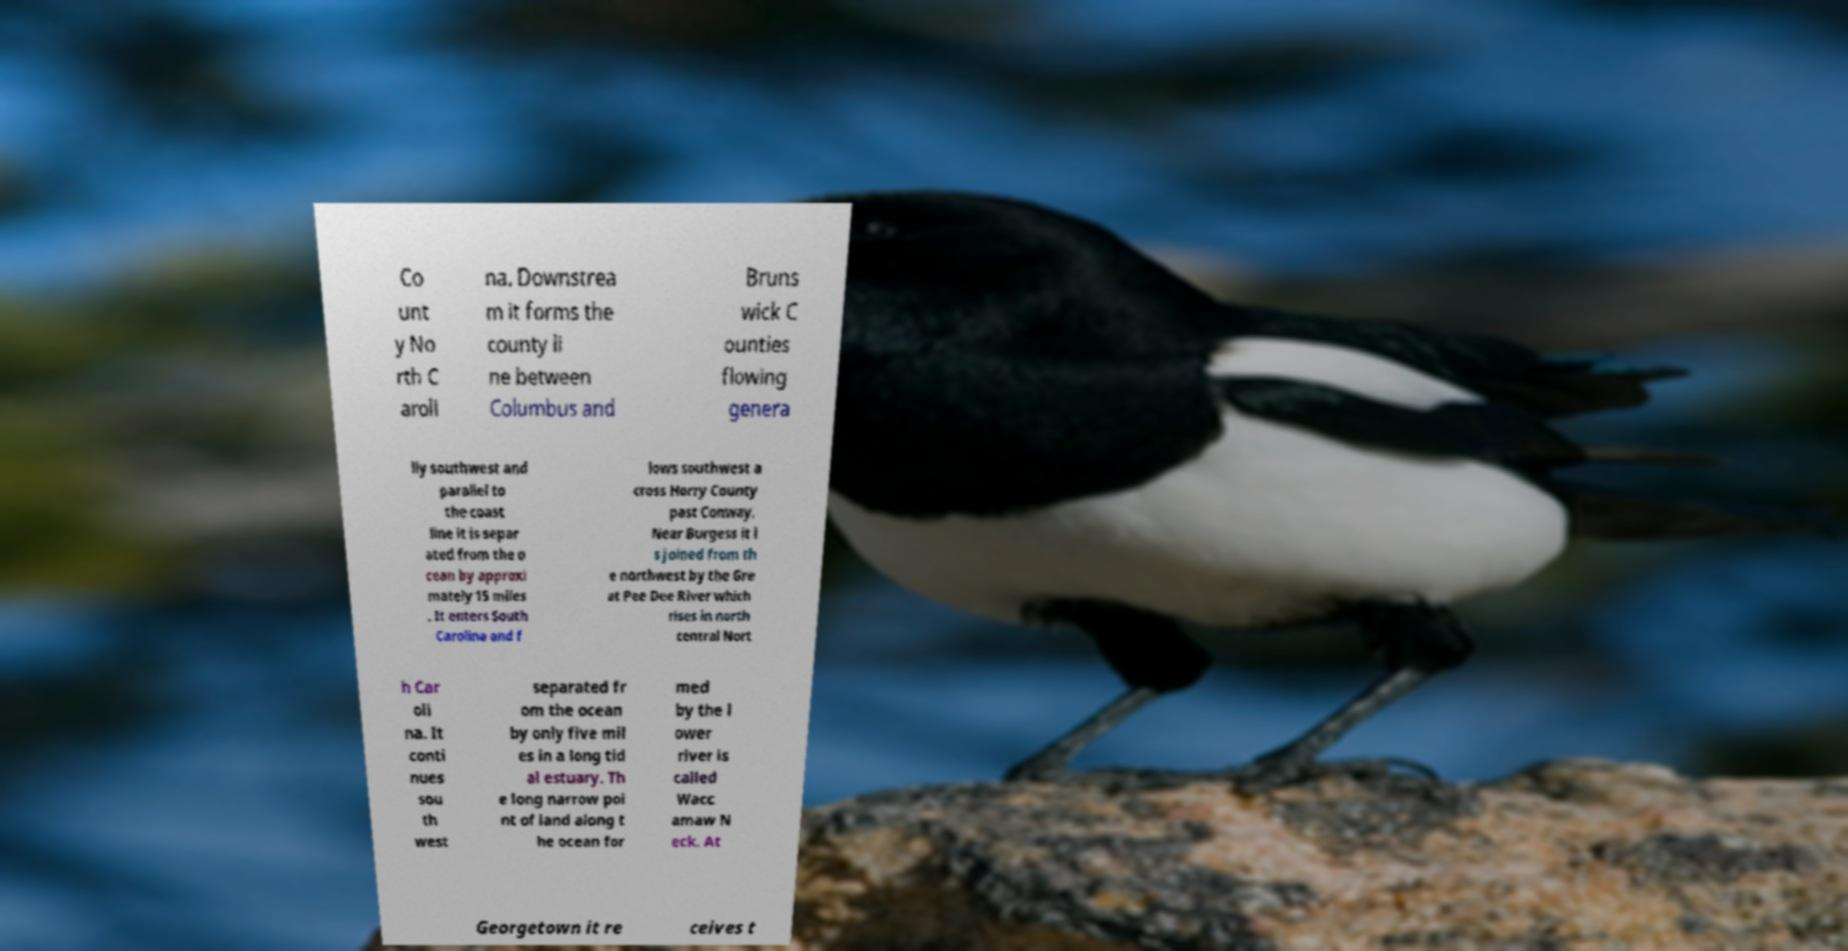Please identify and transcribe the text found in this image. Co unt y No rth C aroli na. Downstrea m it forms the county li ne between Columbus and Bruns wick C ounties flowing genera lly southwest and parallel to the coast line it is separ ated from the o cean by approxi mately 15 miles . It enters South Carolina and f lows southwest a cross Horry County past Conway. Near Burgess it i s joined from th e northwest by the Gre at Pee Dee River which rises in north central Nort h Car oli na. It conti nues sou th west separated fr om the ocean by only five mil es in a long tid al estuary. Th e long narrow poi nt of land along t he ocean for med by the l ower river is called Wacc amaw N eck. At Georgetown it re ceives t 